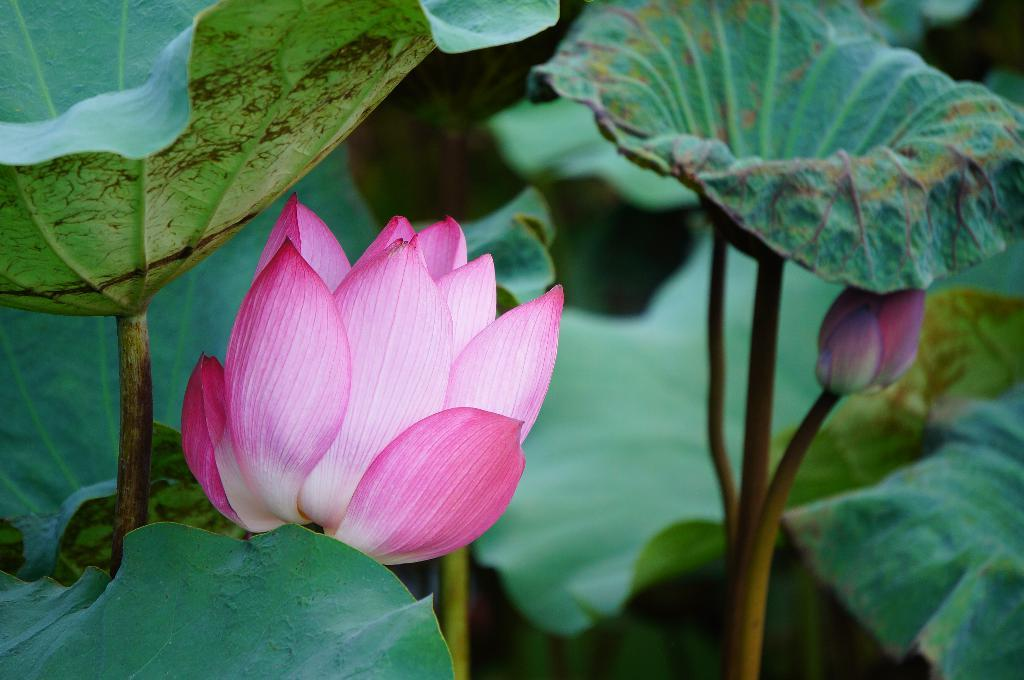What color is the flower on the plant in the image? The flower on the plant is pink. What is the stage of the other bloom on the plant? There is a pink bud on the plant. What type of voice can be heard coming from the store in the image? There is no store present in the image, so it's not possible to determine what, if any, voice might be heard. 